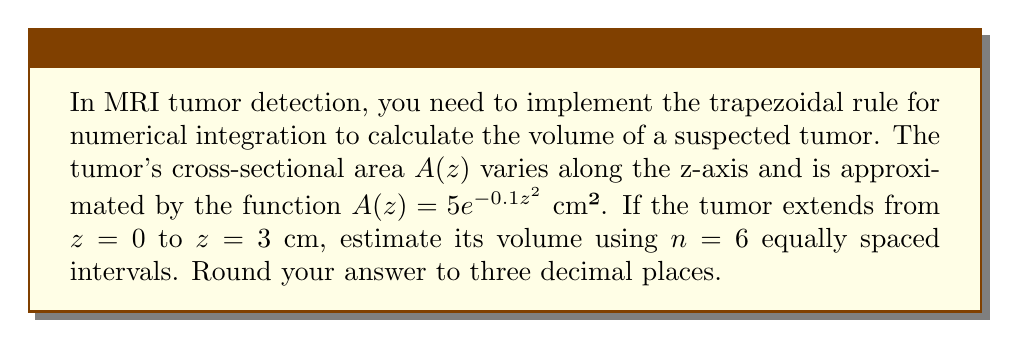What is the answer to this math problem? To solve this problem, we'll use the trapezoidal rule for numerical integration:

1) The trapezoidal rule is given by:
   $$\int_a^b f(x)dx \approx \frac{h}{2}[f(x_0) + 2f(x_1) + 2f(x_2) + ... + 2f(x_{n-1}) + f(x_n)]$$
   where $h = \frac{b-a}{n}$ is the width of each interval.

2) In our case, $a=0$, $b=3$, $n=6$, and $f(z) = A(z) = 5e^{-0.1z^2}$

3) Calculate $h$:
   $h = \frac{3-0}{6} = 0.5$ cm

4) Calculate the z-values:
   $z_0 = 0$, $z_1 = 0.5$, $z_2 = 1$, $z_3 = 1.5$, $z_4 = 2$, $z_5 = 2.5$, $z_6 = 3$

5) Calculate $A(z)$ for each z-value:
   $A(0) = 5e^{-0.1(0)^2} = 5$
   $A(0.5) = 5e^{-0.1(0.5)^2} \approx 4.8779$
   $A(1) = 5e^{-0.1(1)^2} \approx 4.5241$
   $A(1.5) = 5e^{-0.1(1.5)^2} \approx 3.9715$
   $A(2) = 5e^{-0.1(2)^2} \approx 3.2968$
   $A(2.5) = 5e^{-0.1(2.5)^2} \approx 2.5918$
   $A(3) = 5e^{-0.1(3)^2} \approx 1.9274$

6) Apply the trapezoidal rule:
   $$V \approx \frac{0.5}{2}[5 + 2(4.8779 + 4.5241 + 3.9715 + 3.2968 + 2.5918) + 1.9274]$$
   $$V \approx 0.25(5 + 38.4842 + 1.9274) = 0.25(45.4116) = 11.3529$$ cm³

7) Rounding to three decimal places: 11.353 cm³
Answer: 11.353 cm³ 